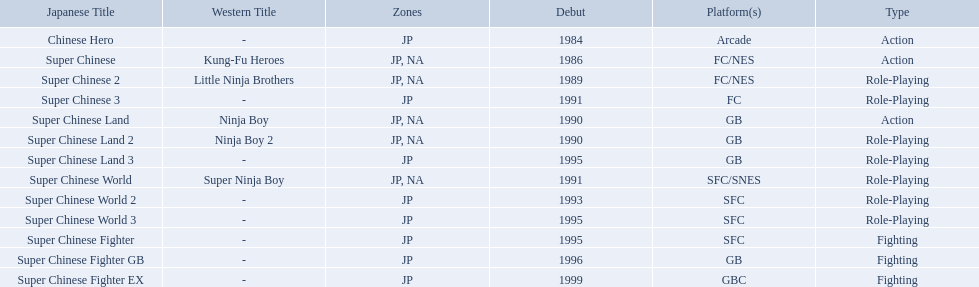Super ninja world was released in what countries? JP, NA. What was the original name for this title? Super Chinese World. 